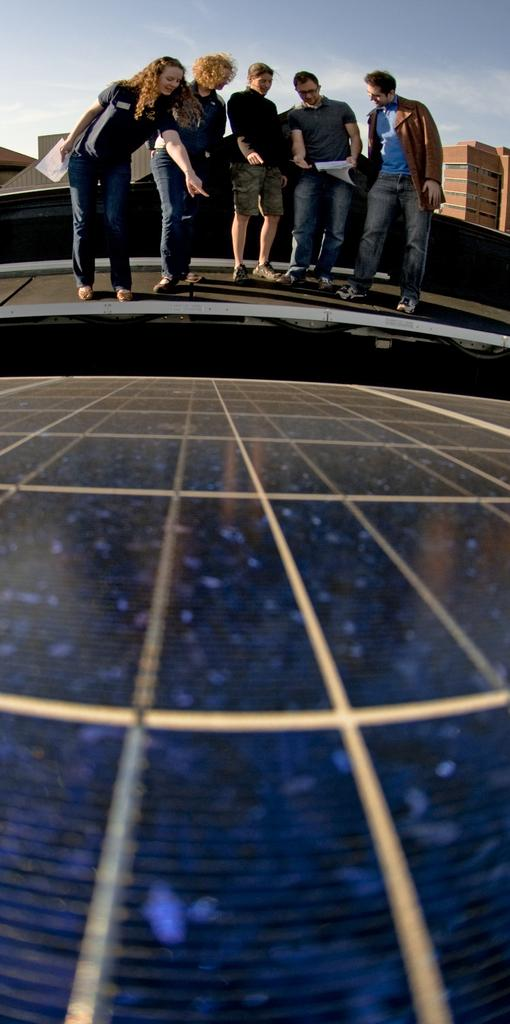What is the main subject of the image? There is an object in the image. What are the people in the image doing? The people are standing on a platform. What can be seen in the background of the image? There are buildings and the sky visible in the background of the image. What type of ear can be seen on the object in the image? There is no ear present on the object in the image. How does the object in the image make people feel? The image does not convey any emotions or feelings associated with the object. 